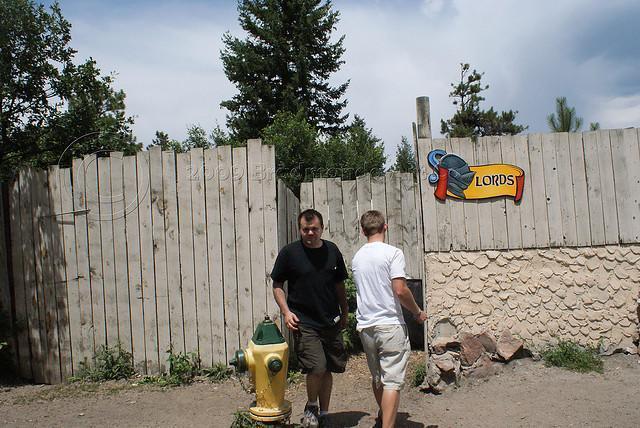How many people are there?
Give a very brief answer. 2. How many orange cones are there?
Give a very brief answer. 0. 